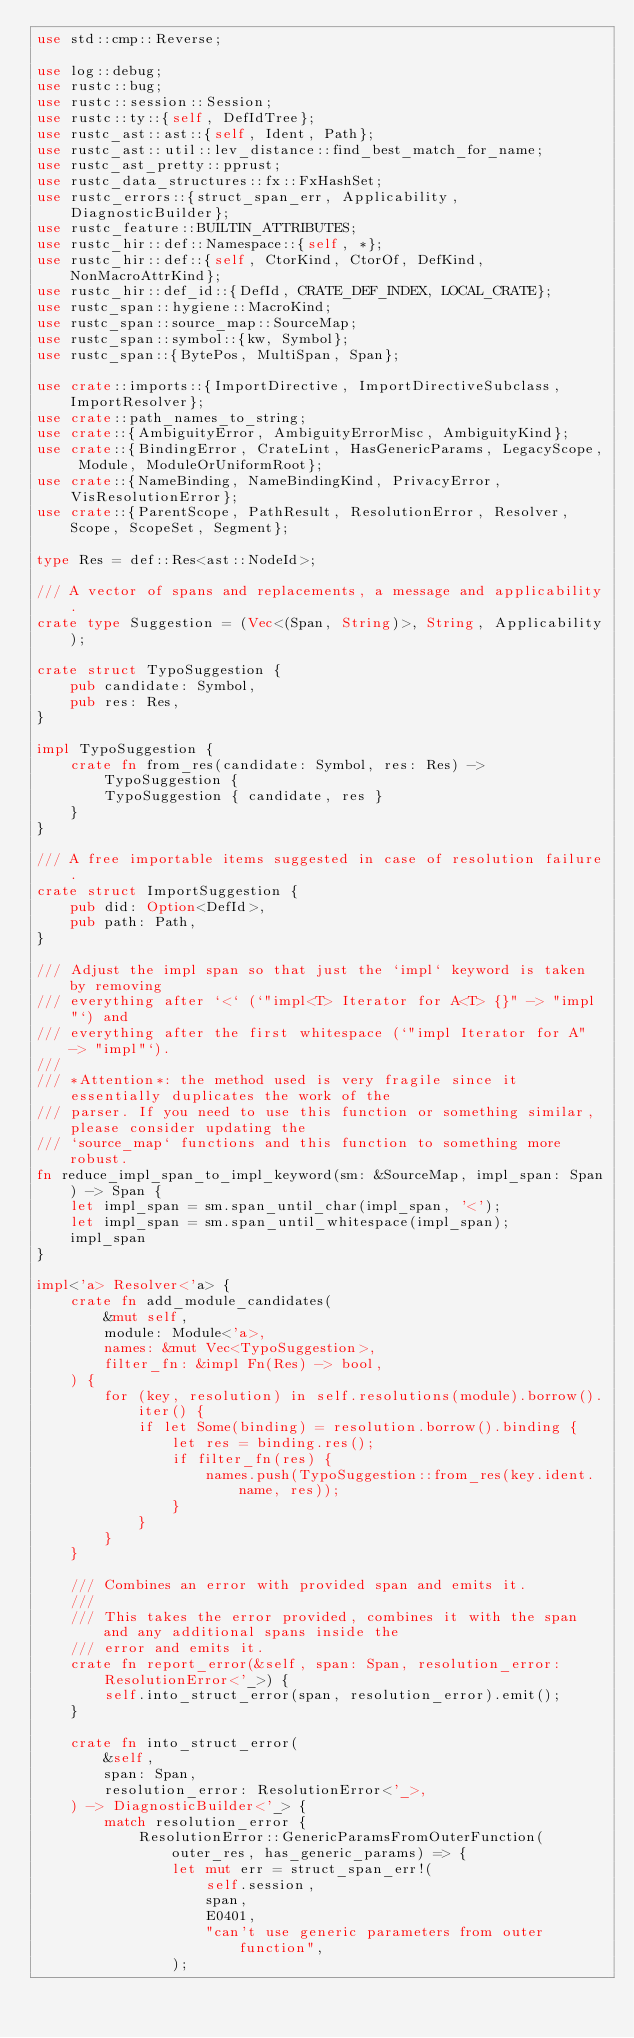<code> <loc_0><loc_0><loc_500><loc_500><_Rust_>use std::cmp::Reverse;

use log::debug;
use rustc::bug;
use rustc::session::Session;
use rustc::ty::{self, DefIdTree};
use rustc_ast::ast::{self, Ident, Path};
use rustc_ast::util::lev_distance::find_best_match_for_name;
use rustc_ast_pretty::pprust;
use rustc_data_structures::fx::FxHashSet;
use rustc_errors::{struct_span_err, Applicability, DiagnosticBuilder};
use rustc_feature::BUILTIN_ATTRIBUTES;
use rustc_hir::def::Namespace::{self, *};
use rustc_hir::def::{self, CtorKind, CtorOf, DefKind, NonMacroAttrKind};
use rustc_hir::def_id::{DefId, CRATE_DEF_INDEX, LOCAL_CRATE};
use rustc_span::hygiene::MacroKind;
use rustc_span::source_map::SourceMap;
use rustc_span::symbol::{kw, Symbol};
use rustc_span::{BytePos, MultiSpan, Span};

use crate::imports::{ImportDirective, ImportDirectiveSubclass, ImportResolver};
use crate::path_names_to_string;
use crate::{AmbiguityError, AmbiguityErrorMisc, AmbiguityKind};
use crate::{BindingError, CrateLint, HasGenericParams, LegacyScope, Module, ModuleOrUniformRoot};
use crate::{NameBinding, NameBindingKind, PrivacyError, VisResolutionError};
use crate::{ParentScope, PathResult, ResolutionError, Resolver, Scope, ScopeSet, Segment};

type Res = def::Res<ast::NodeId>;

/// A vector of spans and replacements, a message and applicability.
crate type Suggestion = (Vec<(Span, String)>, String, Applicability);

crate struct TypoSuggestion {
    pub candidate: Symbol,
    pub res: Res,
}

impl TypoSuggestion {
    crate fn from_res(candidate: Symbol, res: Res) -> TypoSuggestion {
        TypoSuggestion { candidate, res }
    }
}

/// A free importable items suggested in case of resolution failure.
crate struct ImportSuggestion {
    pub did: Option<DefId>,
    pub path: Path,
}

/// Adjust the impl span so that just the `impl` keyword is taken by removing
/// everything after `<` (`"impl<T> Iterator for A<T> {}" -> "impl"`) and
/// everything after the first whitespace (`"impl Iterator for A" -> "impl"`).
///
/// *Attention*: the method used is very fragile since it essentially duplicates the work of the
/// parser. If you need to use this function or something similar, please consider updating the
/// `source_map` functions and this function to something more robust.
fn reduce_impl_span_to_impl_keyword(sm: &SourceMap, impl_span: Span) -> Span {
    let impl_span = sm.span_until_char(impl_span, '<');
    let impl_span = sm.span_until_whitespace(impl_span);
    impl_span
}

impl<'a> Resolver<'a> {
    crate fn add_module_candidates(
        &mut self,
        module: Module<'a>,
        names: &mut Vec<TypoSuggestion>,
        filter_fn: &impl Fn(Res) -> bool,
    ) {
        for (key, resolution) in self.resolutions(module).borrow().iter() {
            if let Some(binding) = resolution.borrow().binding {
                let res = binding.res();
                if filter_fn(res) {
                    names.push(TypoSuggestion::from_res(key.ident.name, res));
                }
            }
        }
    }

    /// Combines an error with provided span and emits it.
    ///
    /// This takes the error provided, combines it with the span and any additional spans inside the
    /// error and emits it.
    crate fn report_error(&self, span: Span, resolution_error: ResolutionError<'_>) {
        self.into_struct_error(span, resolution_error).emit();
    }

    crate fn into_struct_error(
        &self,
        span: Span,
        resolution_error: ResolutionError<'_>,
    ) -> DiagnosticBuilder<'_> {
        match resolution_error {
            ResolutionError::GenericParamsFromOuterFunction(outer_res, has_generic_params) => {
                let mut err = struct_span_err!(
                    self.session,
                    span,
                    E0401,
                    "can't use generic parameters from outer function",
                );</code> 